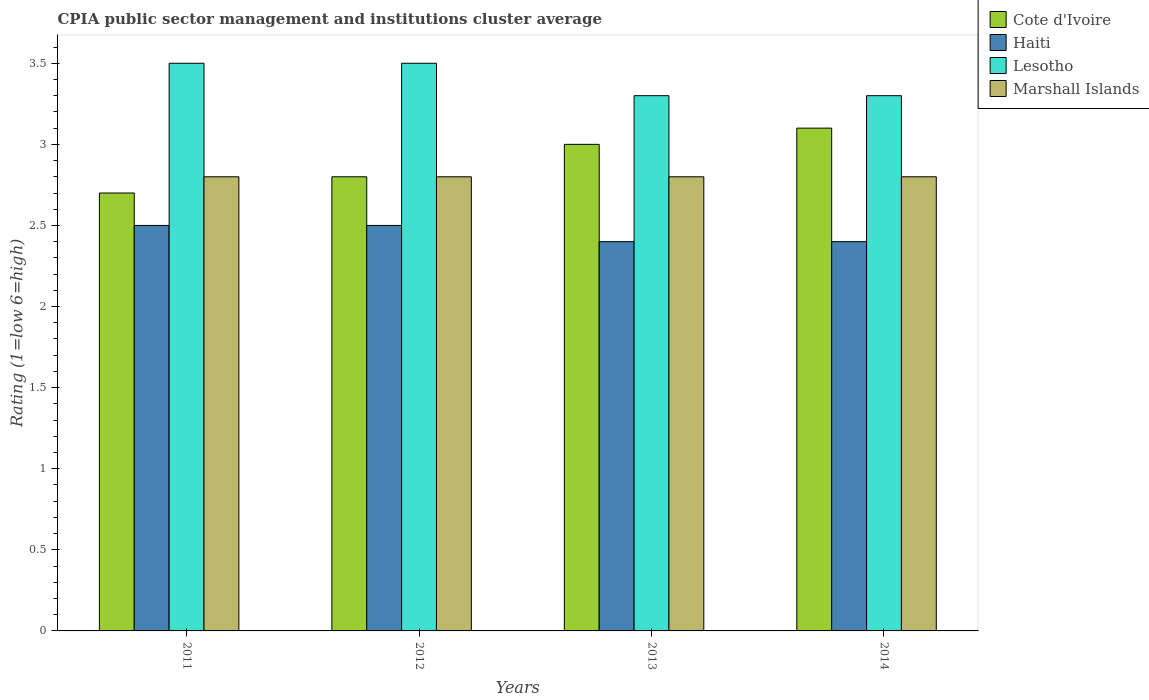How many different coloured bars are there?
Your answer should be very brief. 4. Are the number of bars per tick equal to the number of legend labels?
Offer a very short reply. Yes. How many bars are there on the 1st tick from the left?
Make the answer very short. 4. What is the label of the 2nd group of bars from the left?
Make the answer very short. 2012. In which year was the CPIA rating in Marshall Islands minimum?
Provide a short and direct response. 2011. What is the total CPIA rating in Lesotho in the graph?
Provide a succinct answer. 13.6. What is the difference between the CPIA rating in Cote d'Ivoire in 2012 and that in 2014?
Your answer should be compact. -0.3. What is the difference between the CPIA rating in Cote d'Ivoire in 2011 and the CPIA rating in Marshall Islands in 2014?
Provide a succinct answer. -0.1. What is the average CPIA rating in Lesotho per year?
Offer a terse response. 3.4. In the year 2014, what is the difference between the CPIA rating in Cote d'Ivoire and CPIA rating in Marshall Islands?
Provide a short and direct response. 0.3. What is the ratio of the CPIA rating in Haiti in 2012 to that in 2014?
Provide a short and direct response. 1.04. Is the CPIA rating in Lesotho in 2011 less than that in 2013?
Make the answer very short. No. Is the difference between the CPIA rating in Cote d'Ivoire in 2012 and 2014 greater than the difference between the CPIA rating in Marshall Islands in 2012 and 2014?
Make the answer very short. No. What is the difference between the highest and the lowest CPIA rating in Haiti?
Offer a very short reply. 0.1. In how many years, is the CPIA rating in Marshall Islands greater than the average CPIA rating in Marshall Islands taken over all years?
Offer a terse response. 0. Is it the case that in every year, the sum of the CPIA rating in Haiti and CPIA rating in Cote d'Ivoire is greater than the sum of CPIA rating in Lesotho and CPIA rating in Marshall Islands?
Your response must be concise. No. What does the 3rd bar from the left in 2011 represents?
Ensure brevity in your answer.  Lesotho. What does the 1st bar from the right in 2013 represents?
Offer a very short reply. Marshall Islands. Are all the bars in the graph horizontal?
Offer a terse response. No. How many years are there in the graph?
Offer a terse response. 4. Are the values on the major ticks of Y-axis written in scientific E-notation?
Your response must be concise. No. Does the graph contain any zero values?
Give a very brief answer. No. Does the graph contain grids?
Your answer should be compact. No. How many legend labels are there?
Your response must be concise. 4. What is the title of the graph?
Your answer should be very brief. CPIA public sector management and institutions cluster average. Does "Caribbean small states" appear as one of the legend labels in the graph?
Provide a succinct answer. No. What is the label or title of the X-axis?
Give a very brief answer. Years. What is the label or title of the Y-axis?
Give a very brief answer. Rating (1=low 6=high). What is the Rating (1=low 6=high) in Cote d'Ivoire in 2011?
Give a very brief answer. 2.7. What is the Rating (1=low 6=high) in Lesotho in 2011?
Make the answer very short. 3.5. What is the Rating (1=low 6=high) of Cote d'Ivoire in 2012?
Your answer should be very brief. 2.8. What is the Rating (1=low 6=high) of Lesotho in 2012?
Your response must be concise. 3.5. What is the Rating (1=low 6=high) of Cote d'Ivoire in 2013?
Keep it short and to the point. 3. What is the Rating (1=low 6=high) in Haiti in 2013?
Offer a very short reply. 2.4. What is the Rating (1=low 6=high) of Lesotho in 2013?
Your answer should be very brief. 3.3. What is the Rating (1=low 6=high) in Cote d'Ivoire in 2014?
Provide a short and direct response. 3.1. What is the Rating (1=low 6=high) of Marshall Islands in 2014?
Your answer should be compact. 2.8. Across all years, what is the maximum Rating (1=low 6=high) of Haiti?
Offer a terse response. 2.5. Across all years, what is the minimum Rating (1=low 6=high) in Lesotho?
Provide a short and direct response. 3.3. What is the total Rating (1=low 6=high) in Lesotho in the graph?
Ensure brevity in your answer.  13.6. What is the total Rating (1=low 6=high) in Marshall Islands in the graph?
Provide a succinct answer. 11.2. What is the difference between the Rating (1=low 6=high) in Cote d'Ivoire in 2011 and that in 2012?
Your response must be concise. -0.1. What is the difference between the Rating (1=low 6=high) in Lesotho in 2011 and that in 2012?
Offer a very short reply. 0. What is the difference between the Rating (1=low 6=high) of Marshall Islands in 2011 and that in 2012?
Provide a short and direct response. 0. What is the difference between the Rating (1=low 6=high) in Lesotho in 2011 and that in 2013?
Offer a very short reply. 0.2. What is the difference between the Rating (1=low 6=high) in Cote d'Ivoire in 2011 and that in 2014?
Give a very brief answer. -0.4. What is the difference between the Rating (1=low 6=high) in Haiti in 2011 and that in 2014?
Your response must be concise. 0.1. What is the difference between the Rating (1=low 6=high) in Marshall Islands in 2011 and that in 2014?
Ensure brevity in your answer.  0. What is the difference between the Rating (1=low 6=high) of Cote d'Ivoire in 2012 and that in 2013?
Ensure brevity in your answer.  -0.2. What is the difference between the Rating (1=low 6=high) in Haiti in 2012 and that in 2013?
Keep it short and to the point. 0.1. What is the difference between the Rating (1=low 6=high) in Lesotho in 2012 and that in 2013?
Offer a very short reply. 0.2. What is the difference between the Rating (1=low 6=high) of Marshall Islands in 2012 and that in 2014?
Ensure brevity in your answer.  0. What is the difference between the Rating (1=low 6=high) of Cote d'Ivoire in 2011 and the Rating (1=low 6=high) of Marshall Islands in 2012?
Make the answer very short. -0.1. What is the difference between the Rating (1=low 6=high) in Haiti in 2011 and the Rating (1=low 6=high) in Marshall Islands in 2012?
Your response must be concise. -0.3. What is the difference between the Rating (1=low 6=high) in Lesotho in 2011 and the Rating (1=low 6=high) in Marshall Islands in 2012?
Offer a terse response. 0.7. What is the difference between the Rating (1=low 6=high) in Cote d'Ivoire in 2011 and the Rating (1=low 6=high) in Haiti in 2013?
Keep it short and to the point. 0.3. What is the difference between the Rating (1=low 6=high) in Cote d'Ivoire in 2011 and the Rating (1=low 6=high) in Marshall Islands in 2013?
Your answer should be compact. -0.1. What is the difference between the Rating (1=low 6=high) in Haiti in 2011 and the Rating (1=low 6=high) in Lesotho in 2013?
Your answer should be very brief. -0.8. What is the difference between the Rating (1=low 6=high) in Haiti in 2011 and the Rating (1=low 6=high) in Marshall Islands in 2013?
Ensure brevity in your answer.  -0.3. What is the difference between the Rating (1=low 6=high) in Lesotho in 2011 and the Rating (1=low 6=high) in Marshall Islands in 2013?
Your response must be concise. 0.7. What is the difference between the Rating (1=low 6=high) in Cote d'Ivoire in 2011 and the Rating (1=low 6=high) in Haiti in 2014?
Provide a short and direct response. 0.3. What is the difference between the Rating (1=low 6=high) of Cote d'Ivoire in 2011 and the Rating (1=low 6=high) of Marshall Islands in 2014?
Offer a very short reply. -0.1. What is the difference between the Rating (1=low 6=high) in Haiti in 2011 and the Rating (1=low 6=high) in Lesotho in 2014?
Your response must be concise. -0.8. What is the difference between the Rating (1=low 6=high) of Cote d'Ivoire in 2012 and the Rating (1=low 6=high) of Haiti in 2013?
Offer a very short reply. 0.4. What is the difference between the Rating (1=low 6=high) of Cote d'Ivoire in 2012 and the Rating (1=low 6=high) of Lesotho in 2013?
Give a very brief answer. -0.5. What is the difference between the Rating (1=low 6=high) in Cote d'Ivoire in 2012 and the Rating (1=low 6=high) in Marshall Islands in 2013?
Keep it short and to the point. 0. What is the difference between the Rating (1=low 6=high) of Haiti in 2012 and the Rating (1=low 6=high) of Lesotho in 2013?
Your answer should be compact. -0.8. What is the difference between the Rating (1=low 6=high) of Haiti in 2012 and the Rating (1=low 6=high) of Marshall Islands in 2013?
Give a very brief answer. -0.3. What is the difference between the Rating (1=low 6=high) of Cote d'Ivoire in 2012 and the Rating (1=low 6=high) of Haiti in 2014?
Make the answer very short. 0.4. What is the difference between the Rating (1=low 6=high) in Haiti in 2012 and the Rating (1=low 6=high) in Marshall Islands in 2014?
Ensure brevity in your answer.  -0.3. What is the difference between the Rating (1=low 6=high) in Lesotho in 2012 and the Rating (1=low 6=high) in Marshall Islands in 2014?
Keep it short and to the point. 0.7. What is the difference between the Rating (1=low 6=high) in Cote d'Ivoire in 2013 and the Rating (1=low 6=high) in Haiti in 2014?
Provide a succinct answer. 0.6. What is the difference between the Rating (1=low 6=high) in Cote d'Ivoire in 2013 and the Rating (1=low 6=high) in Marshall Islands in 2014?
Ensure brevity in your answer.  0.2. What is the average Rating (1=low 6=high) of Haiti per year?
Keep it short and to the point. 2.45. What is the average Rating (1=low 6=high) of Marshall Islands per year?
Keep it short and to the point. 2.8. In the year 2011, what is the difference between the Rating (1=low 6=high) in Cote d'Ivoire and Rating (1=low 6=high) in Lesotho?
Keep it short and to the point. -0.8. In the year 2011, what is the difference between the Rating (1=low 6=high) of Cote d'Ivoire and Rating (1=low 6=high) of Marshall Islands?
Provide a short and direct response. -0.1. In the year 2011, what is the difference between the Rating (1=low 6=high) of Lesotho and Rating (1=low 6=high) of Marshall Islands?
Offer a terse response. 0.7. In the year 2012, what is the difference between the Rating (1=low 6=high) in Cote d'Ivoire and Rating (1=low 6=high) in Lesotho?
Provide a short and direct response. -0.7. In the year 2012, what is the difference between the Rating (1=low 6=high) in Cote d'Ivoire and Rating (1=low 6=high) in Marshall Islands?
Provide a succinct answer. 0. In the year 2013, what is the difference between the Rating (1=low 6=high) in Haiti and Rating (1=low 6=high) in Marshall Islands?
Keep it short and to the point. -0.4. In the year 2014, what is the difference between the Rating (1=low 6=high) of Cote d'Ivoire and Rating (1=low 6=high) of Lesotho?
Your response must be concise. -0.2. In the year 2014, what is the difference between the Rating (1=low 6=high) of Cote d'Ivoire and Rating (1=low 6=high) of Marshall Islands?
Provide a short and direct response. 0.3. In the year 2014, what is the difference between the Rating (1=low 6=high) in Haiti and Rating (1=low 6=high) in Lesotho?
Your answer should be very brief. -0.9. In the year 2014, what is the difference between the Rating (1=low 6=high) in Lesotho and Rating (1=low 6=high) in Marshall Islands?
Your answer should be compact. 0.5. What is the ratio of the Rating (1=low 6=high) in Cote d'Ivoire in 2011 to that in 2012?
Give a very brief answer. 0.96. What is the ratio of the Rating (1=low 6=high) in Lesotho in 2011 to that in 2012?
Keep it short and to the point. 1. What is the ratio of the Rating (1=low 6=high) in Marshall Islands in 2011 to that in 2012?
Your answer should be very brief. 1. What is the ratio of the Rating (1=low 6=high) of Cote d'Ivoire in 2011 to that in 2013?
Offer a very short reply. 0.9. What is the ratio of the Rating (1=low 6=high) of Haiti in 2011 to that in 2013?
Offer a terse response. 1.04. What is the ratio of the Rating (1=low 6=high) in Lesotho in 2011 to that in 2013?
Ensure brevity in your answer.  1.06. What is the ratio of the Rating (1=low 6=high) in Marshall Islands in 2011 to that in 2013?
Give a very brief answer. 1. What is the ratio of the Rating (1=low 6=high) in Cote d'Ivoire in 2011 to that in 2014?
Your response must be concise. 0.87. What is the ratio of the Rating (1=low 6=high) in Haiti in 2011 to that in 2014?
Provide a succinct answer. 1.04. What is the ratio of the Rating (1=low 6=high) of Lesotho in 2011 to that in 2014?
Offer a very short reply. 1.06. What is the ratio of the Rating (1=low 6=high) of Cote d'Ivoire in 2012 to that in 2013?
Your answer should be very brief. 0.93. What is the ratio of the Rating (1=low 6=high) in Haiti in 2012 to that in 2013?
Provide a short and direct response. 1.04. What is the ratio of the Rating (1=low 6=high) of Lesotho in 2012 to that in 2013?
Make the answer very short. 1.06. What is the ratio of the Rating (1=low 6=high) in Cote d'Ivoire in 2012 to that in 2014?
Your response must be concise. 0.9. What is the ratio of the Rating (1=low 6=high) in Haiti in 2012 to that in 2014?
Your answer should be compact. 1.04. What is the ratio of the Rating (1=low 6=high) in Lesotho in 2012 to that in 2014?
Give a very brief answer. 1.06. What is the ratio of the Rating (1=low 6=high) of Cote d'Ivoire in 2013 to that in 2014?
Provide a succinct answer. 0.97. What is the ratio of the Rating (1=low 6=high) in Haiti in 2013 to that in 2014?
Make the answer very short. 1. What is the ratio of the Rating (1=low 6=high) in Marshall Islands in 2013 to that in 2014?
Your response must be concise. 1. What is the difference between the highest and the second highest Rating (1=low 6=high) in Haiti?
Offer a terse response. 0. What is the difference between the highest and the second highest Rating (1=low 6=high) of Lesotho?
Your response must be concise. 0. What is the difference between the highest and the second highest Rating (1=low 6=high) of Marshall Islands?
Ensure brevity in your answer.  0. What is the difference between the highest and the lowest Rating (1=low 6=high) in Cote d'Ivoire?
Offer a terse response. 0.4. What is the difference between the highest and the lowest Rating (1=low 6=high) in Haiti?
Give a very brief answer. 0.1. What is the difference between the highest and the lowest Rating (1=low 6=high) in Lesotho?
Make the answer very short. 0.2. What is the difference between the highest and the lowest Rating (1=low 6=high) in Marshall Islands?
Offer a very short reply. 0. 